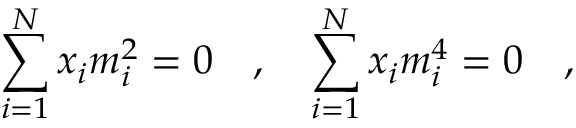Convert formula to latex. <formula><loc_0><loc_0><loc_500><loc_500>\sum _ { i = 1 } ^ { N } x _ { i } m _ { i } ^ { 2 } = 0 , \sum _ { i = 1 } ^ { N } x _ { i } m _ { i } ^ { 4 } = 0 ,</formula> 